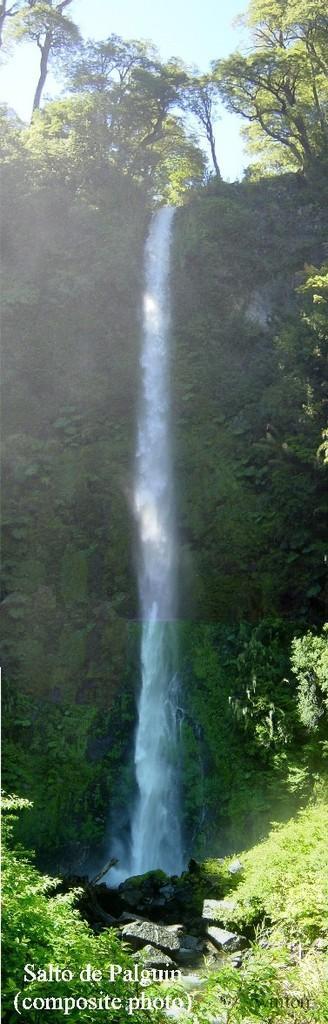Can you describe this image briefly? In this image we can see plants and trees. In the middle of the image waterfall is there. Left bottom of the image watermark is present. 